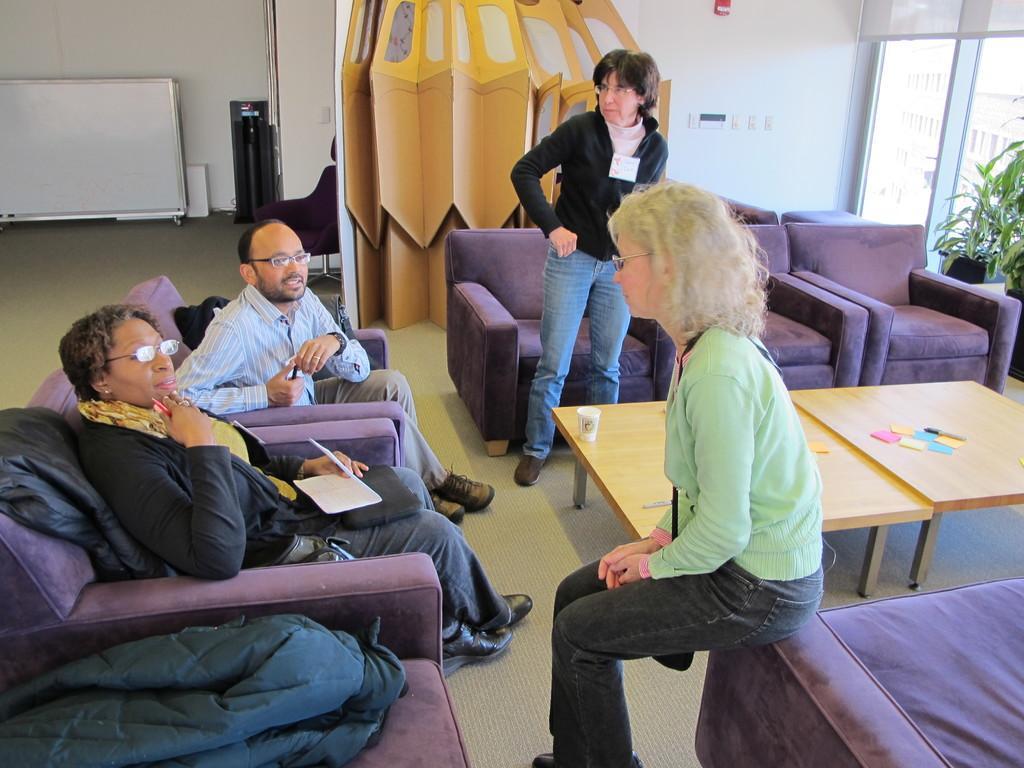Could you give a brief overview of what you see in this image? This picture describes about group of people few are seated on the chair and one person is standing in front of them we can find a cup and papers on the table, in the background we can see a notice board, walls and a plant, and also we can find couple of buildings. 